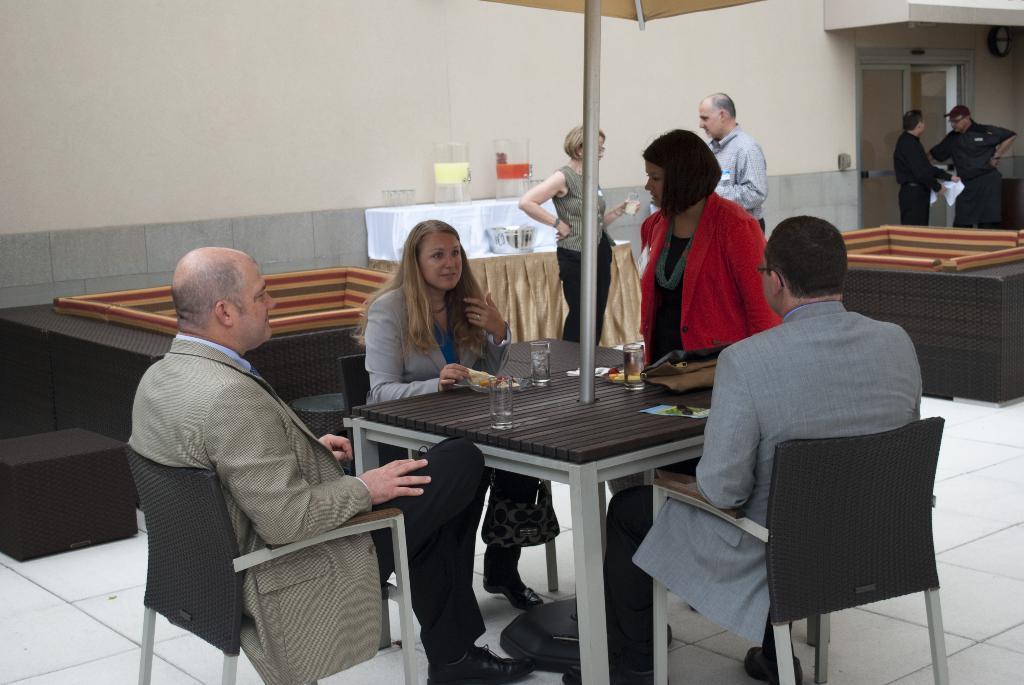Describe this image in one or two sentences. In this image there are group of people sitting in chair ,near the table and in table there are glass, paper and in back ground there are bowl ,cloth, couch , group of people standing, umbrella. 